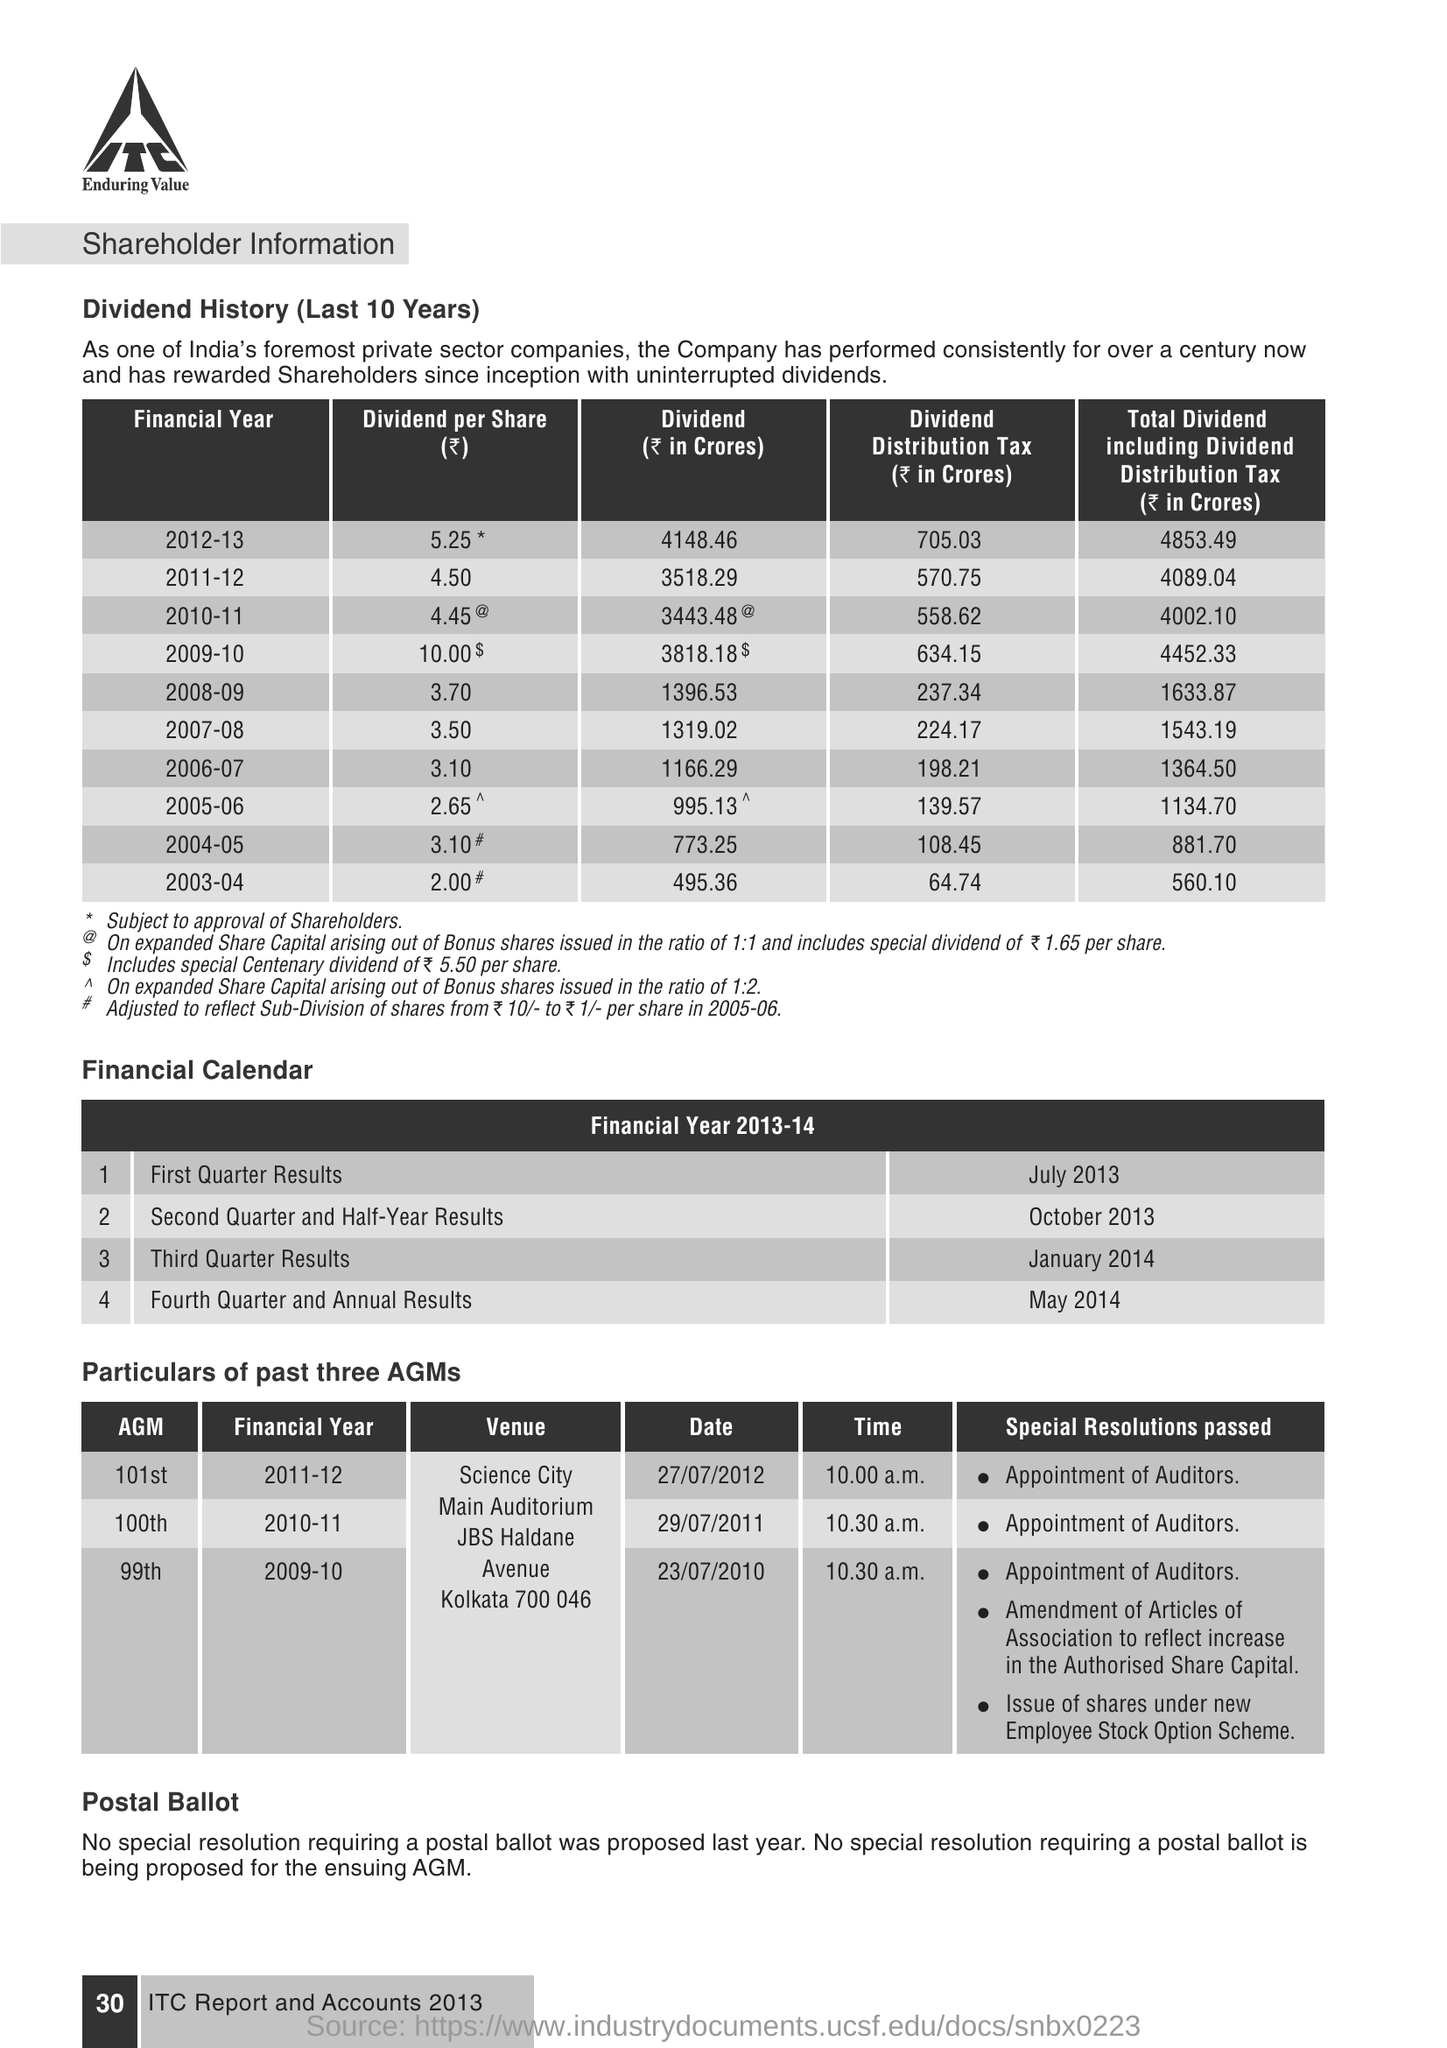List a handful of essential elements in this visual. The first quarter results were announced during the financial year 2013-14 in July 2013. The dividend per share for the financial year 2011-12 was 4.50. The 99th Annual General Meeting (AGM) was held during the financial year 2009-10. The second quarter and half-year results were announced during the financial year 2013-14 in October 2013. The 100th AGM was conducted at 10:30 A.M. 